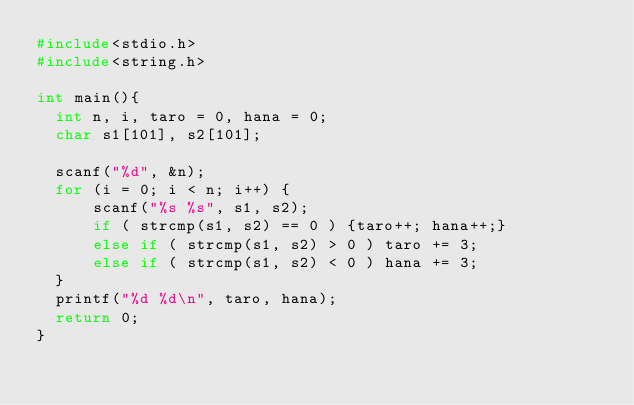Convert code to text. <code><loc_0><loc_0><loc_500><loc_500><_C_>#include<stdio.h>
#include<string.h>

int main(){
  int n, i, taro = 0, hana = 0;
  char s1[101], s2[101];

  scanf("%d", &n);
  for (i = 0; i < n; i++) {
	  scanf("%s %s", s1, s2);
      if ( strcmp(s1, s2) == 0 ) {taro++; hana++;}
      else if ( strcmp(s1, s2) > 0 ) taro += 3;
      else if ( strcmp(s1, s2) < 0 ) hana += 3;
  }
  printf("%d %d\n", taro, hana);
  return 0;
}
</code> 